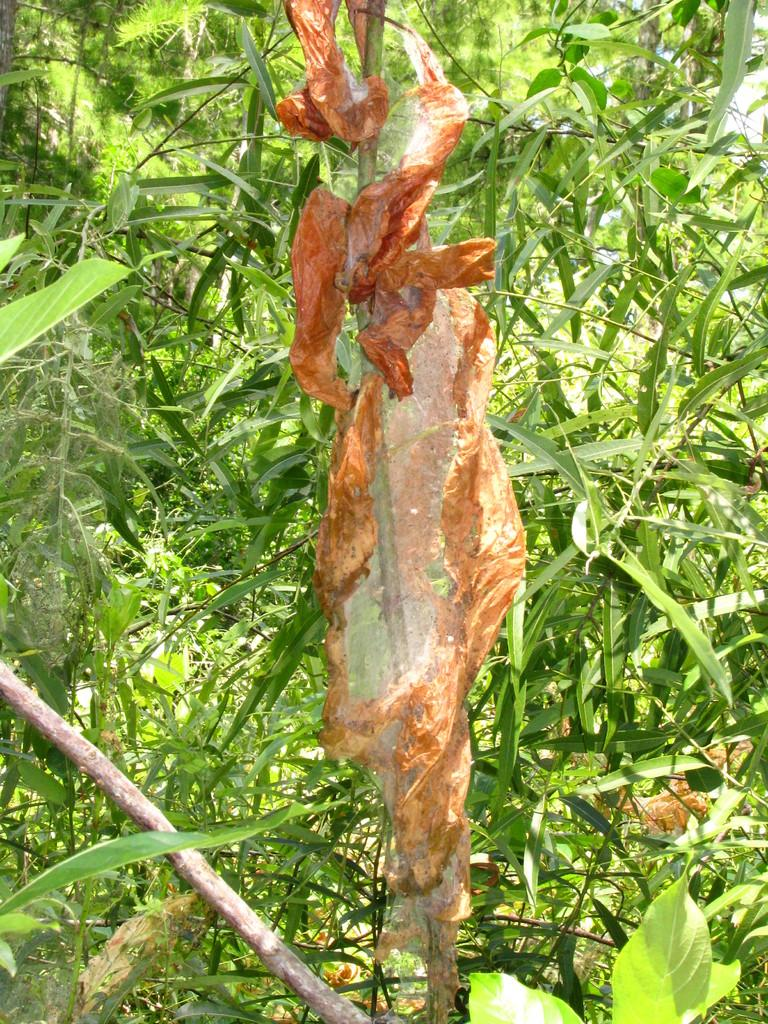What is located in the middle of the image? There are plants and a web formed by dry leaves in the middle of the image. Can you describe the web in the image? The web is formed by dry leaves in the middle of the image. What is at the bottom of the image? There is a stick at the bottom of the image. What type of thread is used to create the desk in the image? There is no desk present in the image, so the type of thread cannot be determined. 